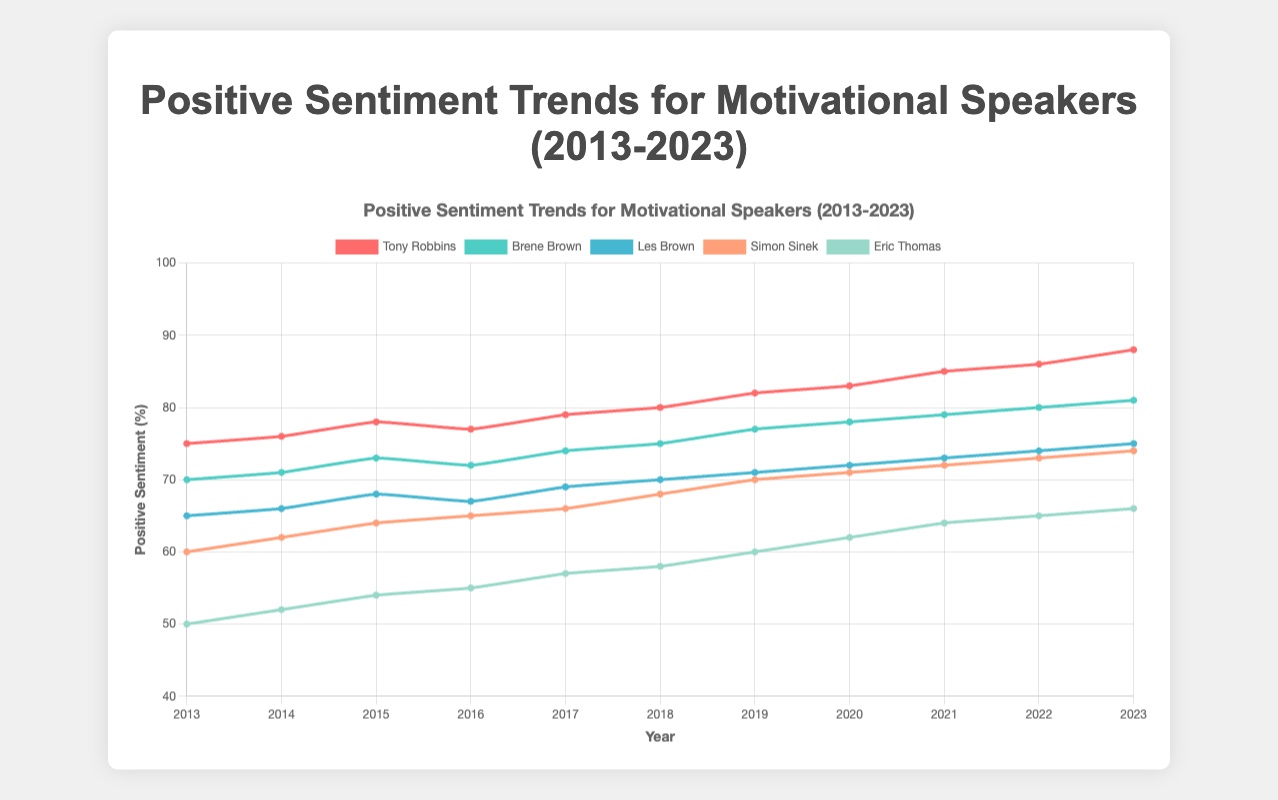What was the positive sentiment percentage for Tony Robbins in 2023, and how does it compare to his 2013 percentage? Tony Robbins had an 88% positive sentiment in 2023 and 75% in 2013. The percentage increased by 13 points over this period (88 - 75 = 13).
Answer: Increased by 13 points Between Brene Brown and Simon Sinek, who had a higher positive sentiment in 2021 and by how much? In 2021, Brene Brown had a positive sentiment of 79%, while Simon Sinek had 72%. Thus, Brene Brown had a higher sentiment by 7 points (79 - 72 = 7).
Answer: Brene Brown by 7 points Which motivational speaker had the highest positive sentiment in 2020? Tony Robbins had the highest positive sentiment in 2020 with 83%. This can be determined by comparing the lines at 2020 on the figure.
Answer: Tony Robbins What was the trend in the positive sentiment for Eric Thomas from 2013 to 2023? From 2013 to 2023, Eric Thomas's positive sentiment increased from 50% to 66%. This trend shows a gradual increase over the decade.
Answer: Increasing trend What's the combined positive sentiment of Les Brown and Simon Sinek in 2015? Les Brown's positive sentiment in 2015 was 68% and Simon Sinek's was 64%. The combined positive sentiment is 68 + 64 = 132%.
Answer: 132% Which motivational speaker showed the steepest increase in positive sentiment from 2017 to 2018? Tony Robbins had a positive sentiment increase from 79% in 2017 to 80% in 2018, a 1-point increase. Simon Sinek grew from 66% to 68%, a 2-point increase. However, considering the consistent trends, Simon Sinek showed a steeper increase for the interval.
Answer: Simon Sinek How did the positive sentiment for Brene Brown change from 2018 to 2019? Brene Brown's positive sentiment increased from 75% in 2018 to 77% in 2019. This indicates a 2-point increase (77 - 75 = 2).
Answer: Increased by 2 points What's the average positive sentiment for all speakers in 2020? Adding the 2020 positive sentiments of Tony Robbins (83%), Brene Brown (78%), Les Brown (72%), Simon Sinek (71%), and Eric Thomas (62%) gives 83 + 78 + 72 + 71 + 62 = 366%. Dividing by 5 speakers, the average is 366 / 5 = 73.2%.
Answer: 73.2% Which speaker had the most significant drop in neutral sentiment from 2013 to 2023? Tony Robbins' neutral sentiment dropped from 15% in 2013 to 2% in 2023. The most significant drop is 15 - 2 = 13 points.
Answer: Tony Robbins What is the difference in positive sentiment between the highest and the lowest motivational speakers in 2016? In 2016, Tony Robbins had the highest positive sentiment at 77%, and Eric Thomas had the lowest at 55%. The difference between them is 77 - 55 = 22 points.
Answer: 22 points 